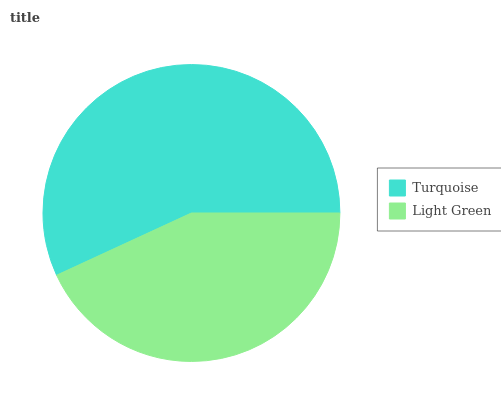Is Light Green the minimum?
Answer yes or no. Yes. Is Turquoise the maximum?
Answer yes or no. Yes. Is Light Green the maximum?
Answer yes or no. No. Is Turquoise greater than Light Green?
Answer yes or no. Yes. Is Light Green less than Turquoise?
Answer yes or no. Yes. Is Light Green greater than Turquoise?
Answer yes or no. No. Is Turquoise less than Light Green?
Answer yes or no. No. Is Turquoise the high median?
Answer yes or no. Yes. Is Light Green the low median?
Answer yes or no. Yes. Is Light Green the high median?
Answer yes or no. No. Is Turquoise the low median?
Answer yes or no. No. 